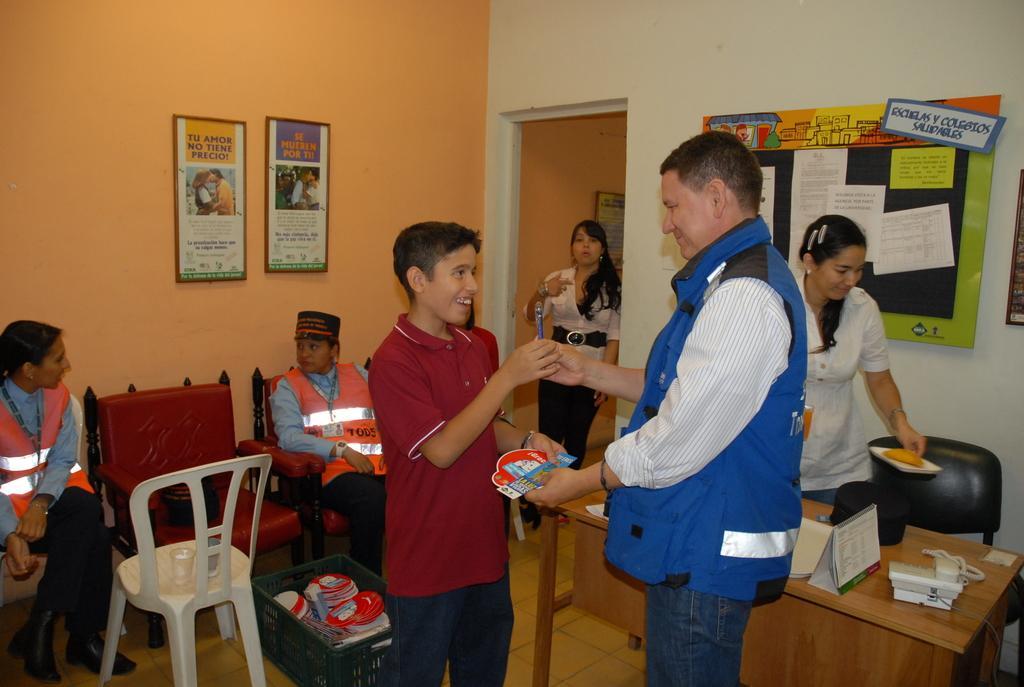Please provide a concise description of this image. As we can see in the image, there are few people. These four people are standing on floor and these two women were sitting on sofa and on the left side there is orange color wall. On wall there are two photo frames. On the right side there is a white color wall and a board, table and a chair. 